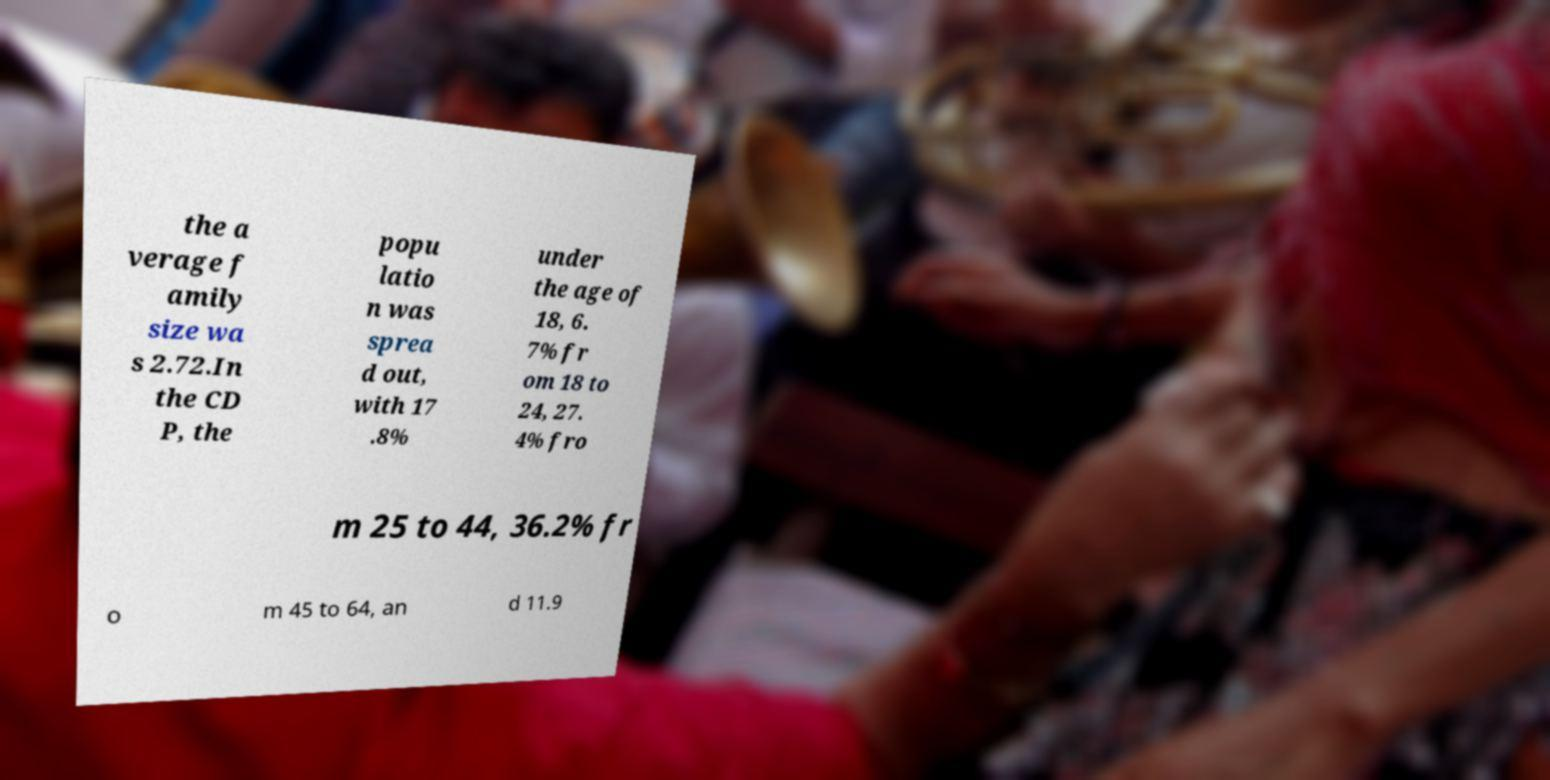There's text embedded in this image that I need extracted. Can you transcribe it verbatim? the a verage f amily size wa s 2.72.In the CD P, the popu latio n was sprea d out, with 17 .8% under the age of 18, 6. 7% fr om 18 to 24, 27. 4% fro m 25 to 44, 36.2% fr o m 45 to 64, an d 11.9 